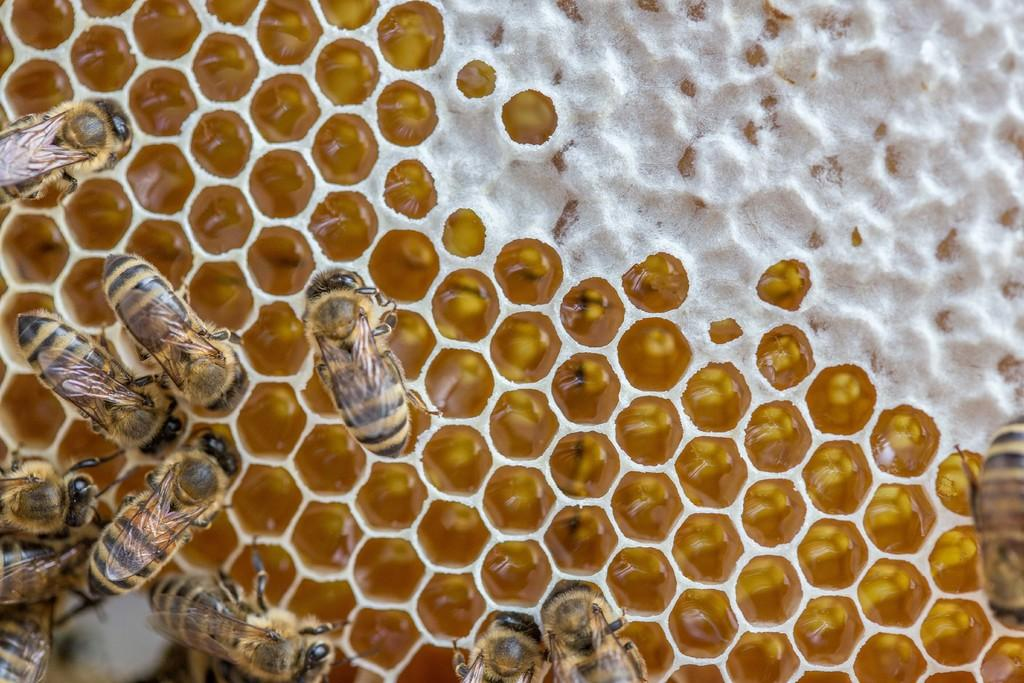What type of insects can be seen in the image? There are honey bees in the image. Where are the honey bees located? The honey bees are on a honeycomb. What colors are present on the honey bees? The honey bees have brown and black coloring. What type of lace can be seen on the honey bees in the image? There is no lace present on the honey bees in the image; they have brown and black coloring. 